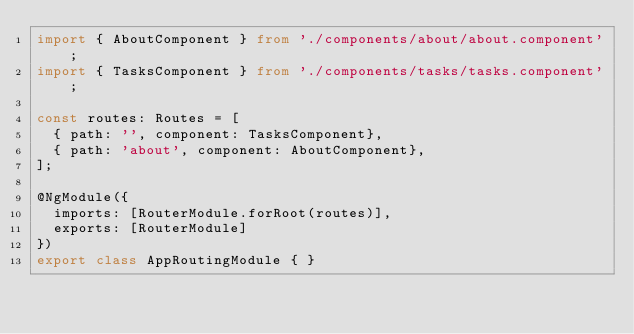<code> <loc_0><loc_0><loc_500><loc_500><_TypeScript_>import { AboutComponent } from './components/about/about.component';
import { TasksComponent } from './components/tasks/tasks.component';

const routes: Routes = [
  { path: '', component: TasksComponent},
  { path: 'about', component: AboutComponent},
];

@NgModule({
  imports: [RouterModule.forRoot(routes)],
  exports: [RouterModule]
})
export class AppRoutingModule { }
</code> 